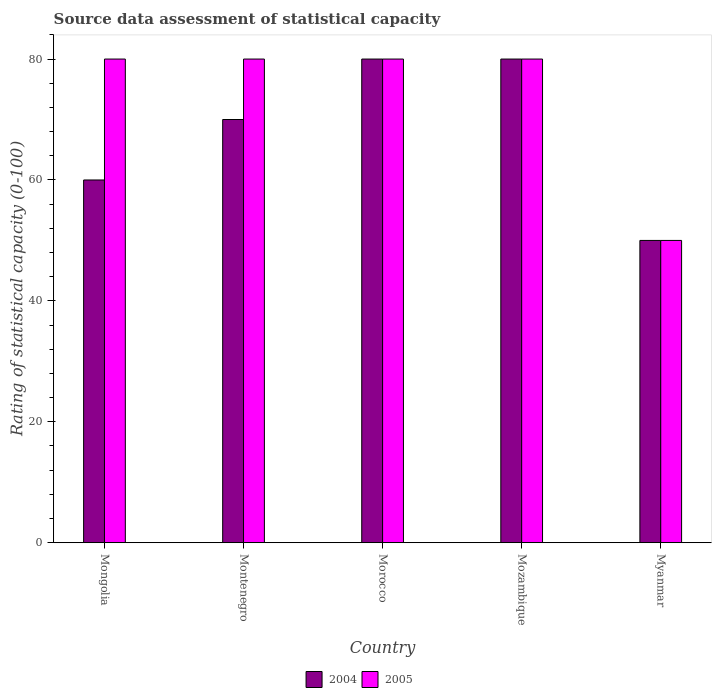How many bars are there on the 5th tick from the left?
Your answer should be compact. 2. How many bars are there on the 4th tick from the right?
Provide a succinct answer. 2. What is the label of the 4th group of bars from the left?
Your answer should be compact. Mozambique. In how many cases, is the number of bars for a given country not equal to the number of legend labels?
Provide a short and direct response. 0. Across all countries, what is the maximum rating of statistical capacity in 2004?
Ensure brevity in your answer.  80. Across all countries, what is the minimum rating of statistical capacity in 2004?
Offer a very short reply. 50. In which country was the rating of statistical capacity in 2004 maximum?
Provide a short and direct response. Morocco. In which country was the rating of statistical capacity in 2005 minimum?
Keep it short and to the point. Myanmar. What is the total rating of statistical capacity in 2005 in the graph?
Provide a short and direct response. 370. What is the difference between the rating of statistical capacity in 2004 in Mongolia and that in Mozambique?
Give a very brief answer. -20. What is the difference between the rating of statistical capacity in 2005 in Myanmar and the rating of statistical capacity in 2004 in Mozambique?
Offer a very short reply. -30. What is the average rating of statistical capacity in 2004 per country?
Offer a terse response. 68. What is the difference between the rating of statistical capacity of/in 2005 and rating of statistical capacity of/in 2004 in Myanmar?
Provide a short and direct response. 0. In how many countries, is the rating of statistical capacity in 2004 greater than 16?
Offer a terse response. 5. What is the ratio of the rating of statistical capacity in 2005 in Mongolia to that in Morocco?
Your response must be concise. 1. Is the rating of statistical capacity in 2005 in Morocco less than that in Mozambique?
Provide a succinct answer. No. What is the difference between the highest and the second highest rating of statistical capacity in 2004?
Give a very brief answer. 10. In how many countries, is the rating of statistical capacity in 2004 greater than the average rating of statistical capacity in 2004 taken over all countries?
Provide a succinct answer. 3. How many bars are there?
Offer a terse response. 10. Are all the bars in the graph horizontal?
Your answer should be very brief. No. How many countries are there in the graph?
Make the answer very short. 5. Are the values on the major ticks of Y-axis written in scientific E-notation?
Provide a succinct answer. No. Does the graph contain any zero values?
Keep it short and to the point. No. How many legend labels are there?
Your answer should be compact. 2. What is the title of the graph?
Keep it short and to the point. Source data assessment of statistical capacity. What is the label or title of the X-axis?
Your answer should be very brief. Country. What is the label or title of the Y-axis?
Your response must be concise. Rating of statistical capacity (0-100). What is the Rating of statistical capacity (0-100) in 2005 in Mongolia?
Make the answer very short. 80. What is the Rating of statistical capacity (0-100) in 2004 in Mozambique?
Offer a very short reply. 80. What is the Rating of statistical capacity (0-100) of 2005 in Myanmar?
Provide a short and direct response. 50. Across all countries, what is the maximum Rating of statistical capacity (0-100) of 2005?
Provide a short and direct response. 80. Across all countries, what is the minimum Rating of statistical capacity (0-100) in 2004?
Give a very brief answer. 50. What is the total Rating of statistical capacity (0-100) of 2004 in the graph?
Your response must be concise. 340. What is the total Rating of statistical capacity (0-100) of 2005 in the graph?
Offer a terse response. 370. What is the difference between the Rating of statistical capacity (0-100) in 2004 in Mongolia and that in Montenegro?
Your answer should be very brief. -10. What is the difference between the Rating of statistical capacity (0-100) in 2005 in Mongolia and that in Montenegro?
Ensure brevity in your answer.  0. What is the difference between the Rating of statistical capacity (0-100) of 2004 in Mongolia and that in Morocco?
Ensure brevity in your answer.  -20. What is the difference between the Rating of statistical capacity (0-100) of 2005 in Mongolia and that in Myanmar?
Ensure brevity in your answer.  30. What is the difference between the Rating of statistical capacity (0-100) in 2004 in Montenegro and that in Morocco?
Ensure brevity in your answer.  -10. What is the difference between the Rating of statistical capacity (0-100) of 2005 in Montenegro and that in Mozambique?
Provide a succinct answer. 0. What is the difference between the Rating of statistical capacity (0-100) in 2004 in Montenegro and that in Myanmar?
Make the answer very short. 20. What is the difference between the Rating of statistical capacity (0-100) of 2004 in Morocco and that in Mozambique?
Make the answer very short. 0. What is the difference between the Rating of statistical capacity (0-100) of 2005 in Morocco and that in Mozambique?
Give a very brief answer. 0. What is the difference between the Rating of statistical capacity (0-100) of 2004 in Morocco and that in Myanmar?
Ensure brevity in your answer.  30. What is the difference between the Rating of statistical capacity (0-100) of 2005 in Morocco and that in Myanmar?
Your answer should be compact. 30. What is the difference between the Rating of statistical capacity (0-100) of 2004 in Mozambique and that in Myanmar?
Provide a short and direct response. 30. What is the difference between the Rating of statistical capacity (0-100) in 2004 in Mongolia and the Rating of statistical capacity (0-100) in 2005 in Montenegro?
Offer a very short reply. -20. What is the difference between the Rating of statistical capacity (0-100) in 2004 in Montenegro and the Rating of statistical capacity (0-100) in 2005 in Morocco?
Give a very brief answer. -10. What is the difference between the Rating of statistical capacity (0-100) of 2004 in Morocco and the Rating of statistical capacity (0-100) of 2005 in Myanmar?
Offer a very short reply. 30. What is the difference between the Rating of statistical capacity (0-100) of 2004 in Mozambique and the Rating of statistical capacity (0-100) of 2005 in Myanmar?
Provide a short and direct response. 30. What is the difference between the Rating of statistical capacity (0-100) of 2004 and Rating of statistical capacity (0-100) of 2005 in Montenegro?
Your answer should be compact. -10. What is the difference between the Rating of statistical capacity (0-100) in 2004 and Rating of statistical capacity (0-100) in 2005 in Myanmar?
Make the answer very short. 0. What is the ratio of the Rating of statistical capacity (0-100) in 2005 in Mongolia to that in Montenegro?
Keep it short and to the point. 1. What is the ratio of the Rating of statistical capacity (0-100) in 2004 in Mongolia to that in Morocco?
Keep it short and to the point. 0.75. What is the ratio of the Rating of statistical capacity (0-100) of 2005 in Mongolia to that in Morocco?
Ensure brevity in your answer.  1. What is the ratio of the Rating of statistical capacity (0-100) in 2005 in Montenegro to that in Morocco?
Provide a succinct answer. 1. What is the ratio of the Rating of statistical capacity (0-100) of 2004 in Montenegro to that in Myanmar?
Offer a terse response. 1.4. What is the ratio of the Rating of statistical capacity (0-100) of 2004 in Morocco to that in Mozambique?
Your answer should be compact. 1. What is the ratio of the Rating of statistical capacity (0-100) of 2005 in Morocco to that in Mozambique?
Provide a succinct answer. 1. What is the ratio of the Rating of statistical capacity (0-100) of 2005 in Morocco to that in Myanmar?
Offer a terse response. 1.6. What is the ratio of the Rating of statistical capacity (0-100) of 2004 in Mozambique to that in Myanmar?
Your response must be concise. 1.6. What is the difference between the highest and the lowest Rating of statistical capacity (0-100) in 2004?
Provide a short and direct response. 30. 